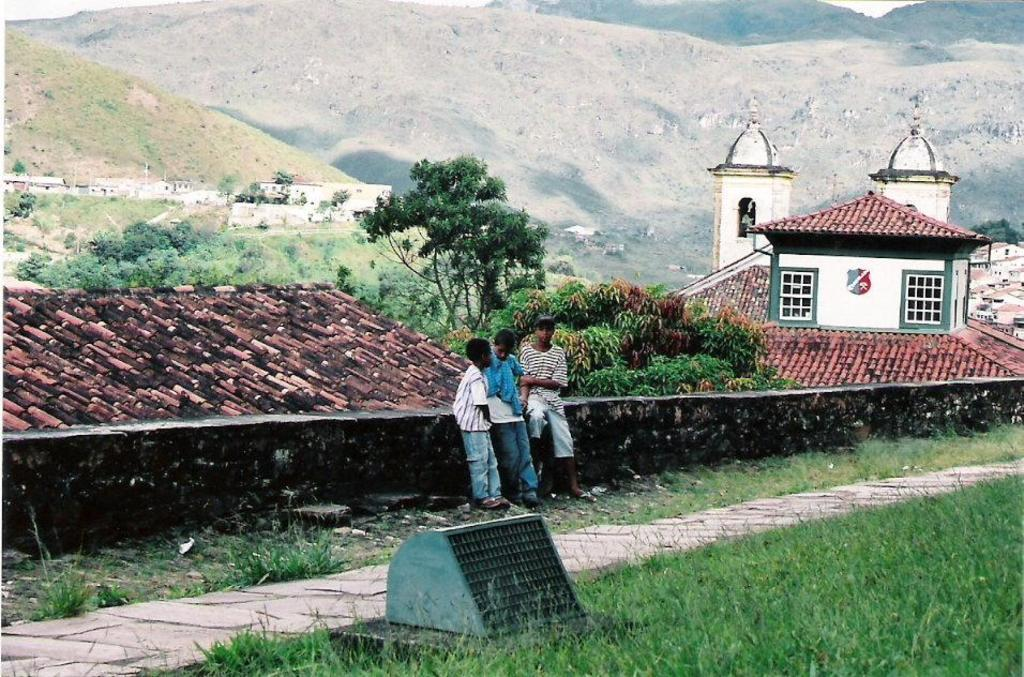How many kids are in the image? There are three kids standing on the ground in the image. What can be seen in the background of the image? In the background of the image, there are houses, trees, plants, grass, the sky, and other objects. What is the ground surface like where the kids are standing? The ground surface is not specified in the facts, but it can be inferred that it is likely grass or a similar surface, given the presence of grass in the background. How does the comparison between the kids and the houses in the image affect the existence of the trees? There is no comparison between the kids and the houses mentioned in the image, and the existence of trees is not affected by any comparison. 